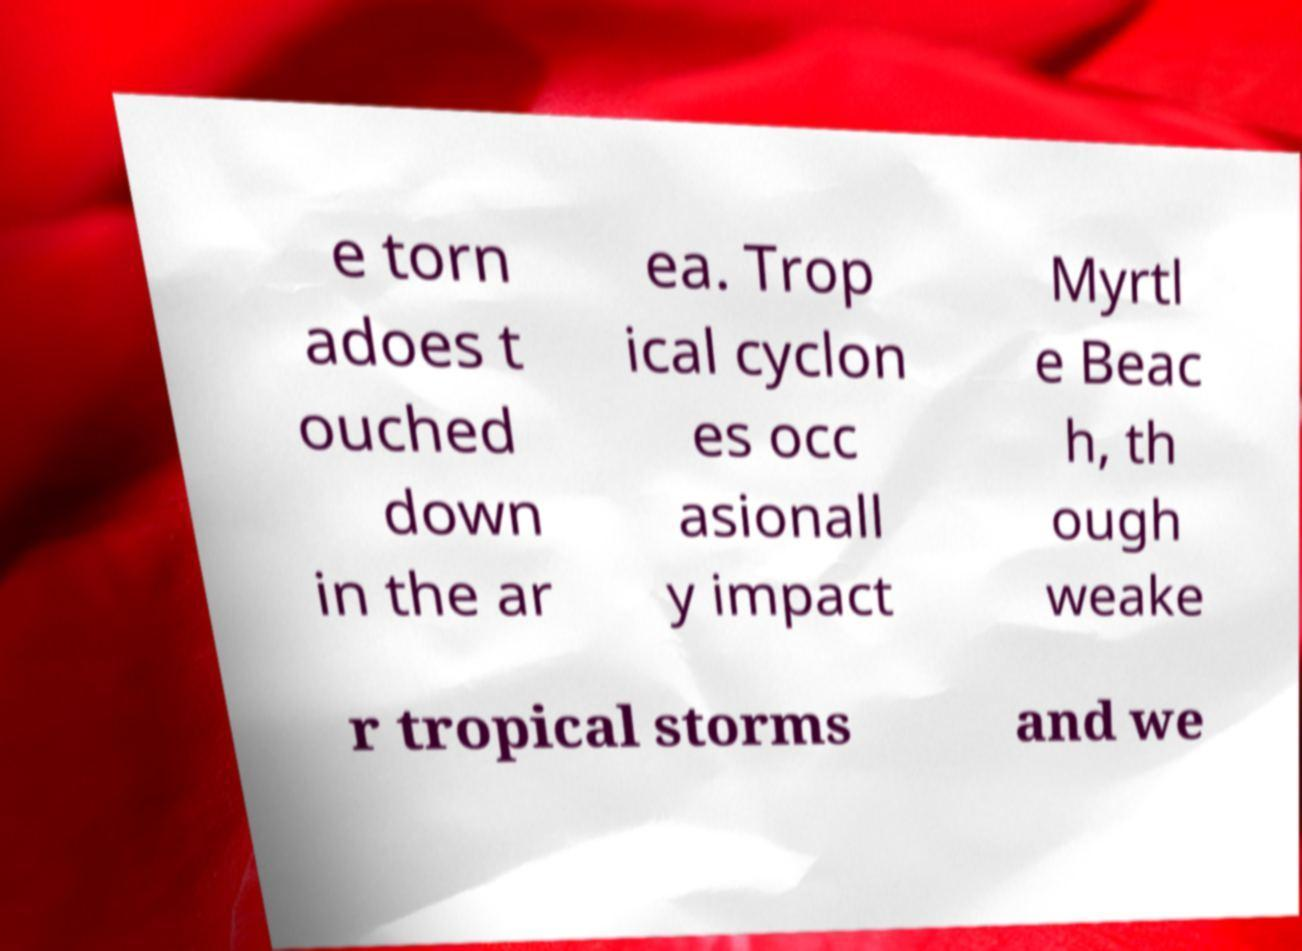Could you extract and type out the text from this image? e torn adoes t ouched down in the ar ea. Trop ical cyclon es occ asionall y impact Myrtl e Beac h, th ough weake r tropical storms and we 